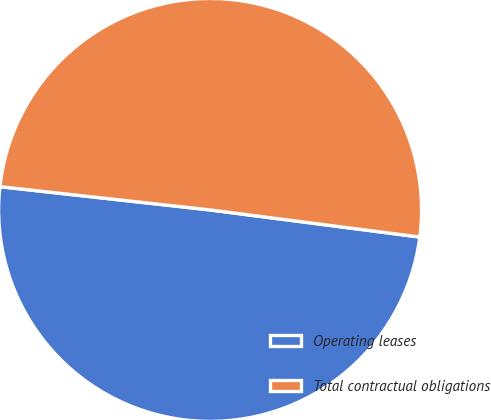Convert chart to OTSL. <chart><loc_0><loc_0><loc_500><loc_500><pie_chart><fcel>Operating leases<fcel>Total contractual obligations<nl><fcel>49.71%<fcel>50.29%<nl></chart> 